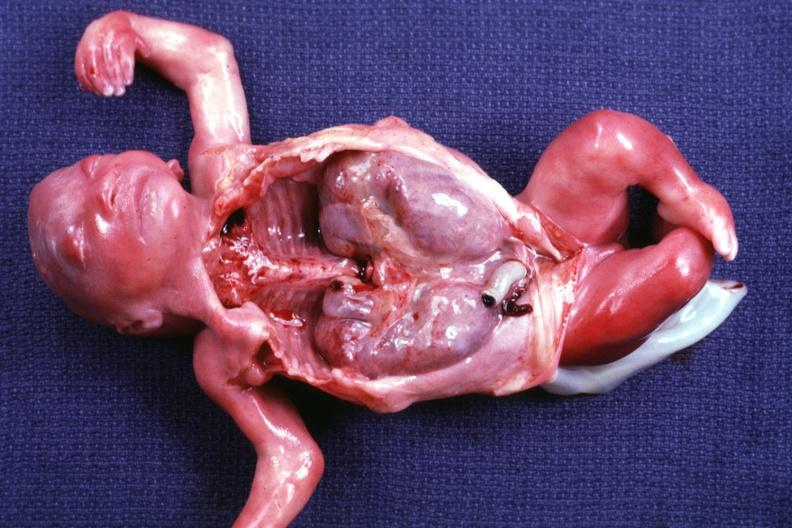what is opened dysmorphic body with all organs except kidneys removed?
Answer the question using a single word or phrase. Shows size of quite well and renal facies 